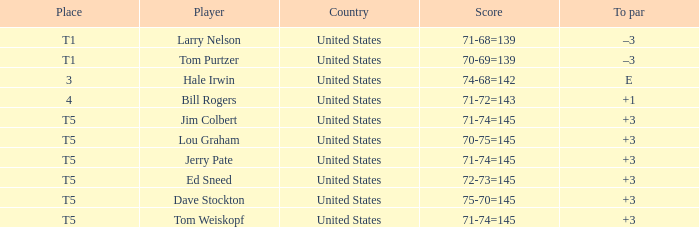What is the country of player ed sneed with a to par of +3? United States. 